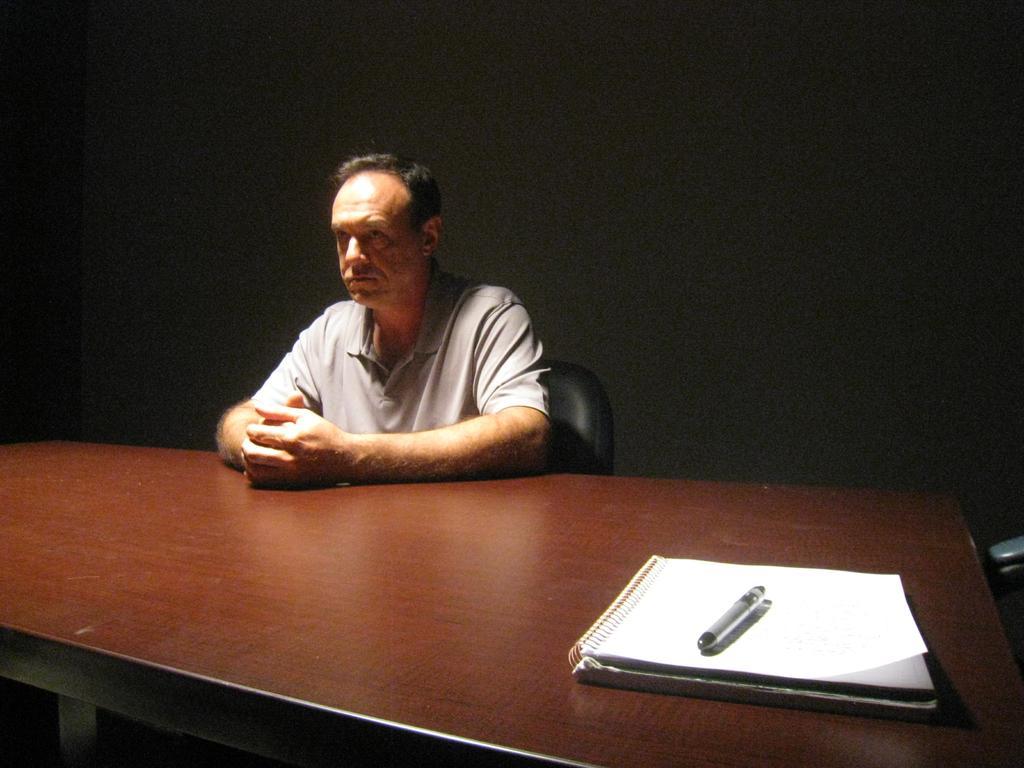Please provide a concise description of this image. In the center we can see one person sitting on the chair around the table. On table,we can see book and pen. In the background there is a wall. 